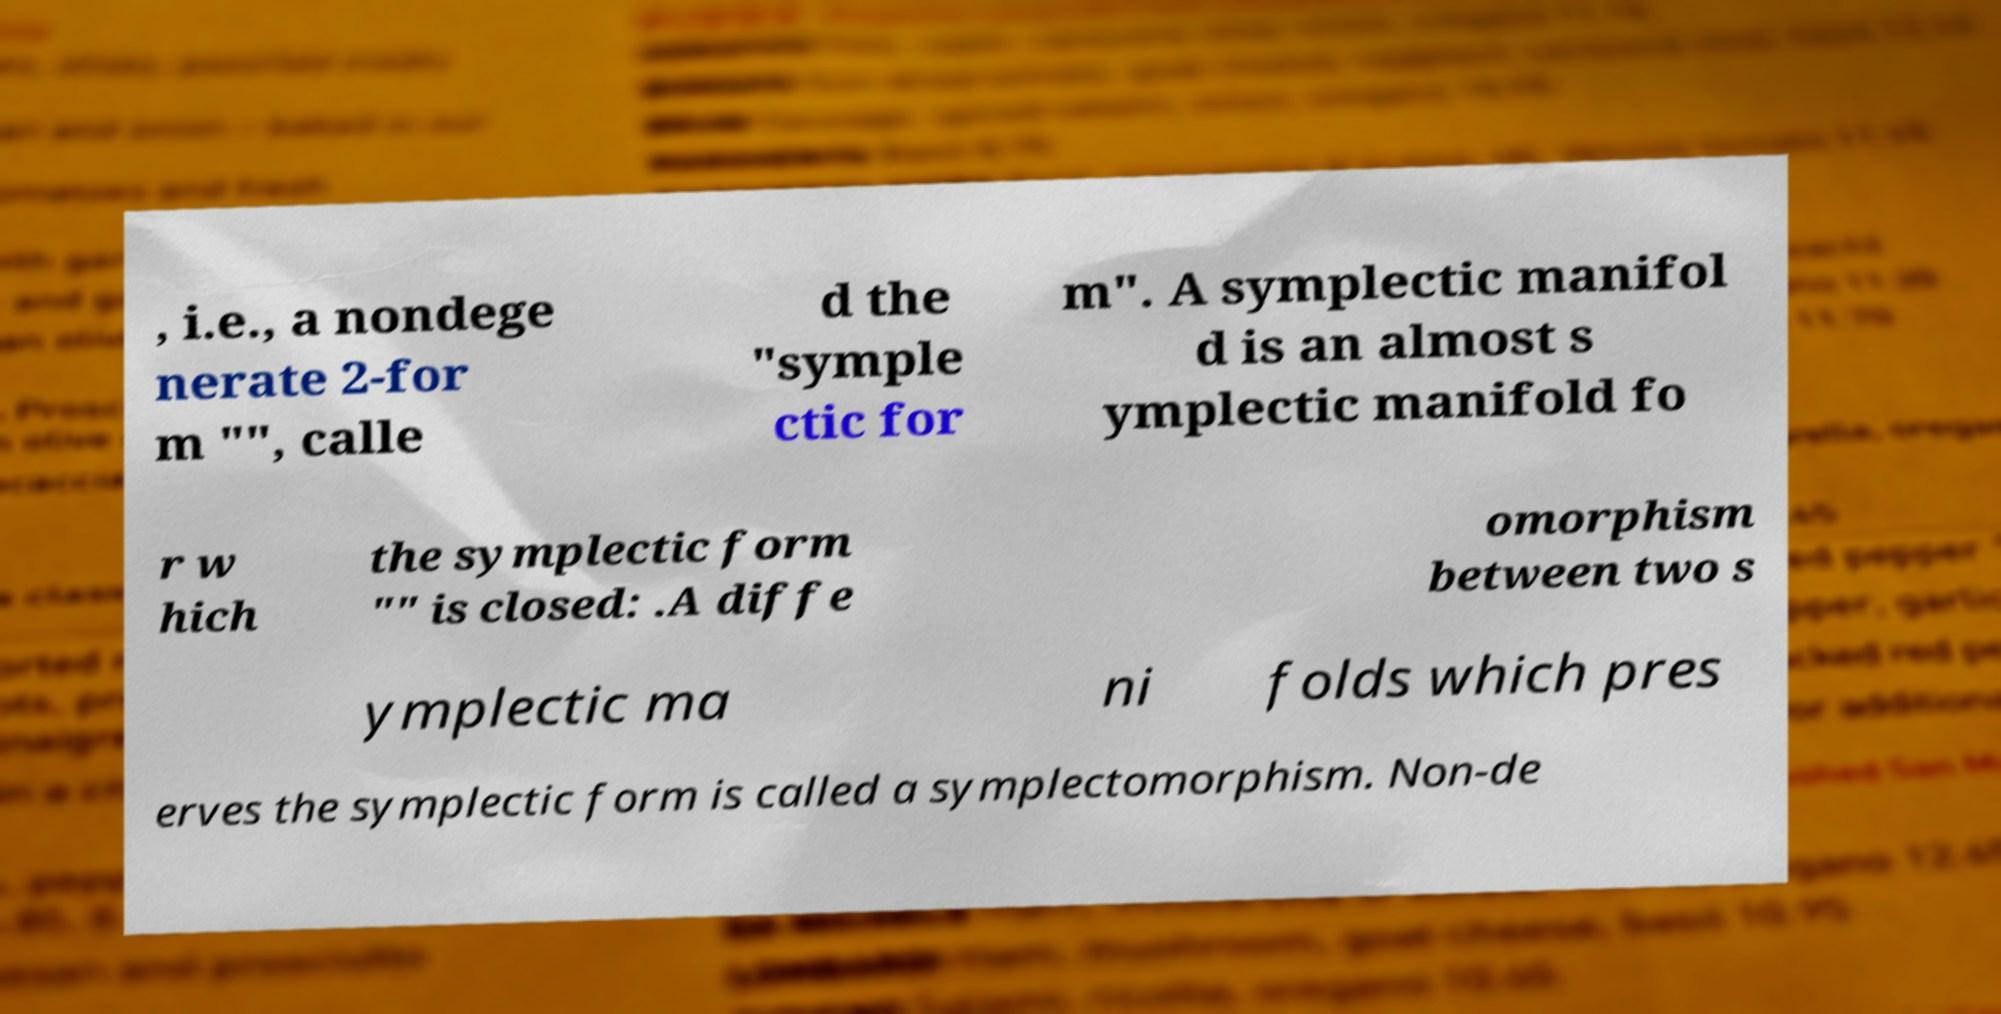There's text embedded in this image that I need extracted. Can you transcribe it verbatim? , i.e., a nondege nerate 2-for m "", calle d the "symple ctic for m". A symplectic manifol d is an almost s ymplectic manifold fo r w hich the symplectic form "" is closed: .A diffe omorphism between two s ymplectic ma ni folds which pres erves the symplectic form is called a symplectomorphism. Non-de 